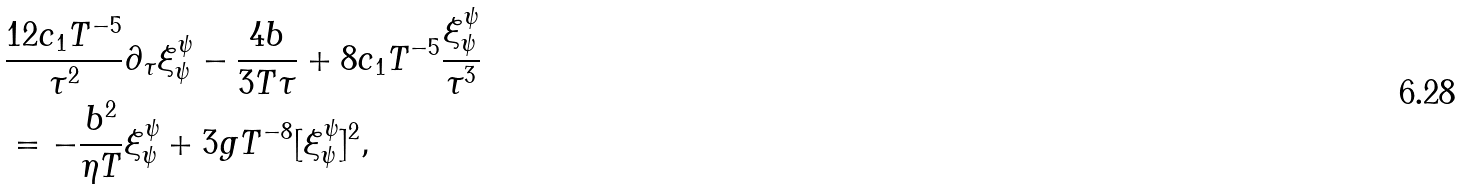Convert formula to latex. <formula><loc_0><loc_0><loc_500><loc_500>& \frac { 1 2 c _ { 1 } T ^ { - 5 } } { \tau ^ { 2 } } \partial _ { \tau } \xi ^ { \psi } _ { \psi } - \frac { 4 b } { 3 T \tau } + 8 c _ { 1 } T ^ { - 5 } \frac { \xi ^ { \psi } _ { \psi } } { \tau ^ { 3 } } \\ & = - \frac { b ^ { 2 } } { \eta T } \xi ^ { \psi } _ { \psi } + 3 g T ^ { - 8 } [ \xi ^ { \psi } _ { \psi } ] ^ { 2 } ,</formula> 